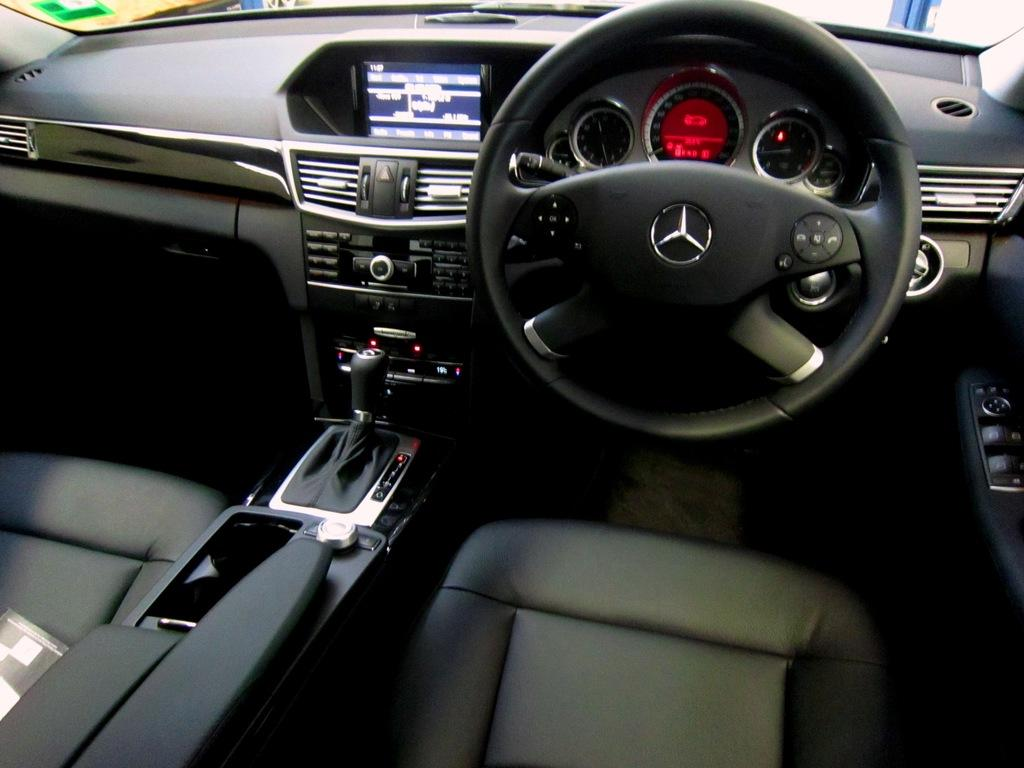What is the main subject of the image? The main subject of the image is a car. What features can be seen inside the car? The car has a steering wheel, a dashboard, and a music player. How many seats are visible in the car? The car has seats, but the exact number cannot be determined from the image. What type of beds can be seen in the car's trunk in the image? There are no beds visible in the image, as it features a car with its interior and music player. Can you tell me how many bats are hanging from the car's roof in the image? There are no bats present in the image; it features a car with its interior and music player. 